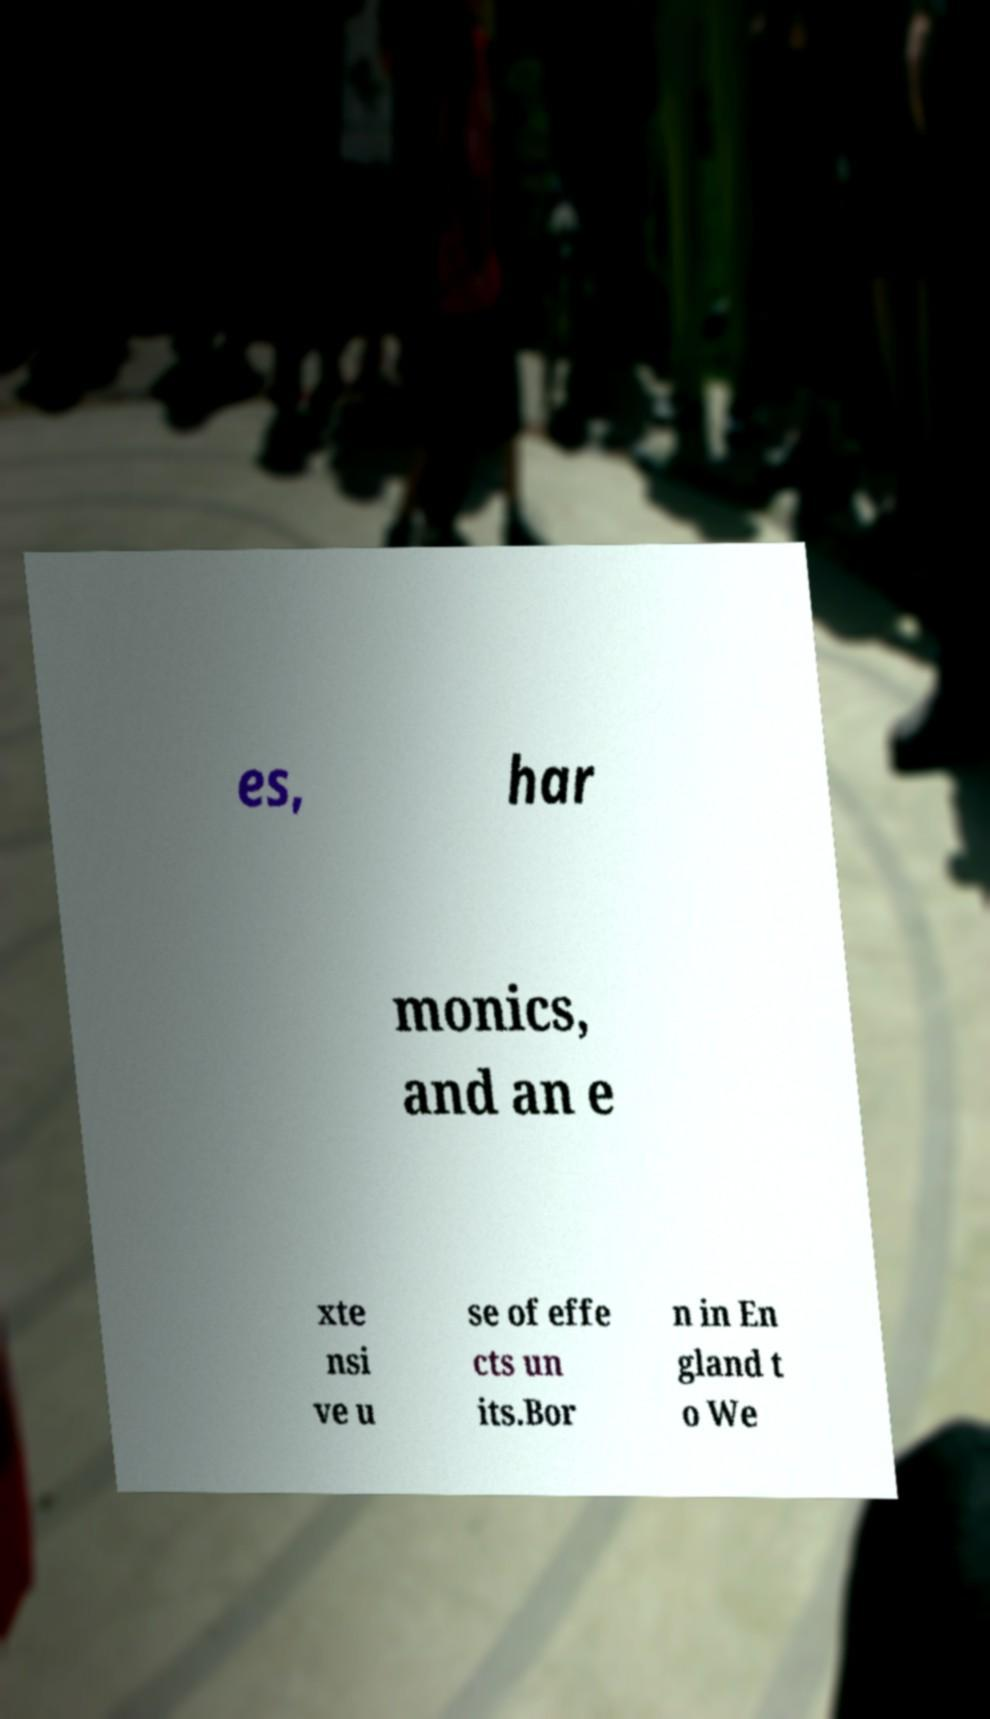Could you extract and type out the text from this image? es, har monics, and an e xte nsi ve u se of effe cts un its.Bor n in En gland t o We 